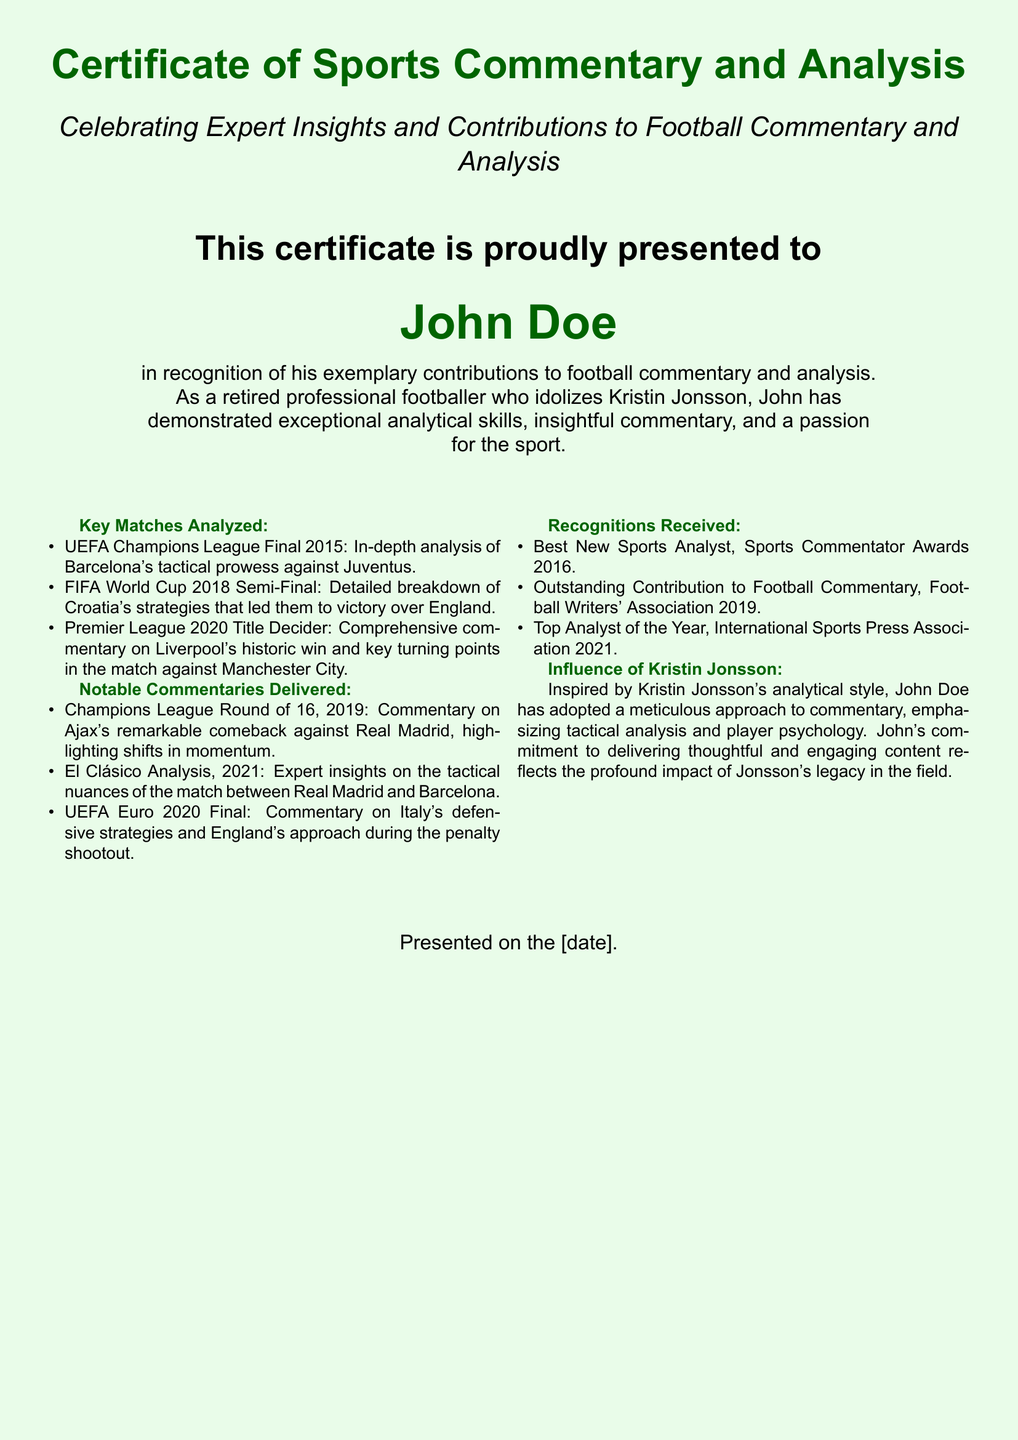What is the name of the recipient of the certificate? The recipient's name is prominently displayed at the center of the document.
Answer: John Doe In which year was the Best New Sports Analyst award received? The award is listed under recognitions received, providing a specific year.
Answer: 2016 What major football event is analyzed in the certificate? The document lists key matches analyzed, including significant football events.
Answer: UEFA Champions League Final 2015 Who is acknowledged as an influence on John Doe's analytical style? The document explicitly mentions the influence on John's commentary approach.
Answer: Kristin Jonsson How many notable commentaries are delivered as mentioned in the document? The count of items listed under notable commentaries provides this information.
Answer: Three What was the title of the award received in 2021? The document provides specific titles for each recognition, detailing the year and title.
Answer: Top Analyst of the Year What aspect of commentary does John emphasize based on Kristin Jonsson’s influence? The effect of Jonsson's influence is specified regarding John's approach to commentary.
Answer: Tactical analysis What year was the Outstanding Contribution to Football Commentary award received? The year of the recognition is specified in the list of awards received.
Answer: 2019 What type of document is this? The main title of the document clearly indicates its type.
Answer: Certificate of Sports Commentary and Analysis 